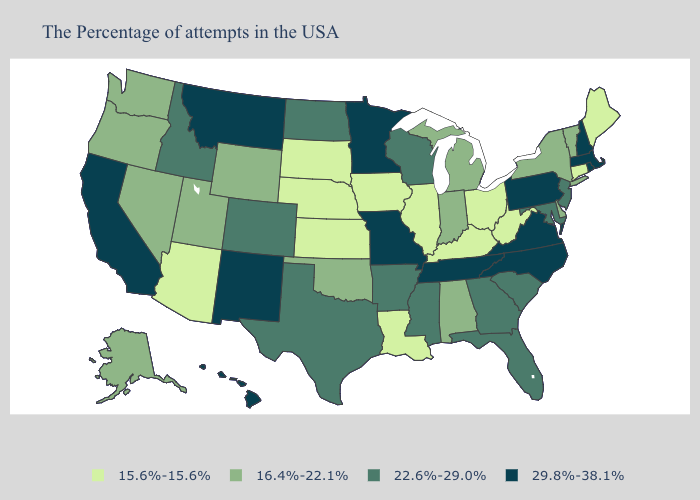Name the states that have a value in the range 29.8%-38.1%?
Give a very brief answer. Massachusetts, Rhode Island, New Hampshire, Pennsylvania, Virginia, North Carolina, Tennessee, Missouri, Minnesota, New Mexico, Montana, California, Hawaii. Among the states that border Oklahoma , does Kansas have the lowest value?
Give a very brief answer. Yes. What is the lowest value in the Northeast?
Keep it brief. 15.6%-15.6%. What is the value of Nebraska?
Answer briefly. 15.6%-15.6%. Name the states that have a value in the range 15.6%-15.6%?
Be succinct. Maine, Connecticut, West Virginia, Ohio, Kentucky, Illinois, Louisiana, Iowa, Kansas, Nebraska, South Dakota, Arizona. Name the states that have a value in the range 29.8%-38.1%?
Answer briefly. Massachusetts, Rhode Island, New Hampshire, Pennsylvania, Virginia, North Carolina, Tennessee, Missouri, Minnesota, New Mexico, Montana, California, Hawaii. What is the lowest value in states that border South Dakota?
Write a very short answer. 15.6%-15.6%. What is the value of Vermont?
Write a very short answer. 16.4%-22.1%. What is the value of Oregon?
Be succinct. 16.4%-22.1%. What is the value of South Dakota?
Concise answer only. 15.6%-15.6%. What is the value of Iowa?
Give a very brief answer. 15.6%-15.6%. Among the states that border Illinois , does Wisconsin have the highest value?
Give a very brief answer. No. What is the value of West Virginia?
Short answer required. 15.6%-15.6%. 